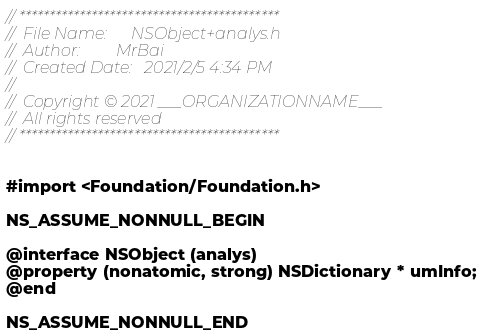<code> <loc_0><loc_0><loc_500><loc_500><_C_>// *******************************************
//  File Name:      NSObject+analys.h       
//  Author:         MrBai
//  Created Date:   2021/2/5 4:34 PM
//    
//  Copyright © 2021 ___ORGANIZATIONNAME___
//  All rights reserved
// *******************************************
    

#import <Foundation/Foundation.h>

NS_ASSUME_NONNULL_BEGIN

@interface NSObject (analys)
@property (nonatomic, strong) NSDictionary * umInfo;
@end

NS_ASSUME_NONNULL_END
</code> 